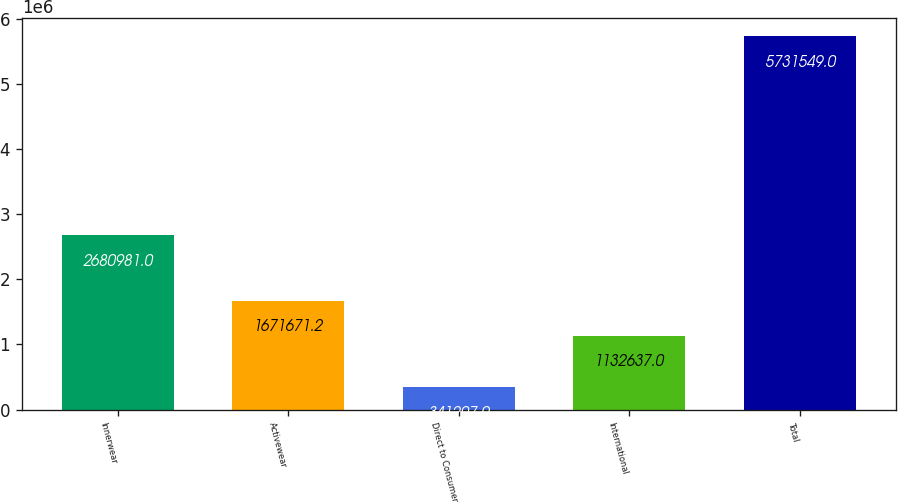Convert chart. <chart><loc_0><loc_0><loc_500><loc_500><bar_chart><fcel>Innerwear<fcel>Activewear<fcel>Direct to Consumer<fcel>International<fcel>Total<nl><fcel>2.68098e+06<fcel>1.67167e+06<fcel>341207<fcel>1.13264e+06<fcel>5.73155e+06<nl></chart> 